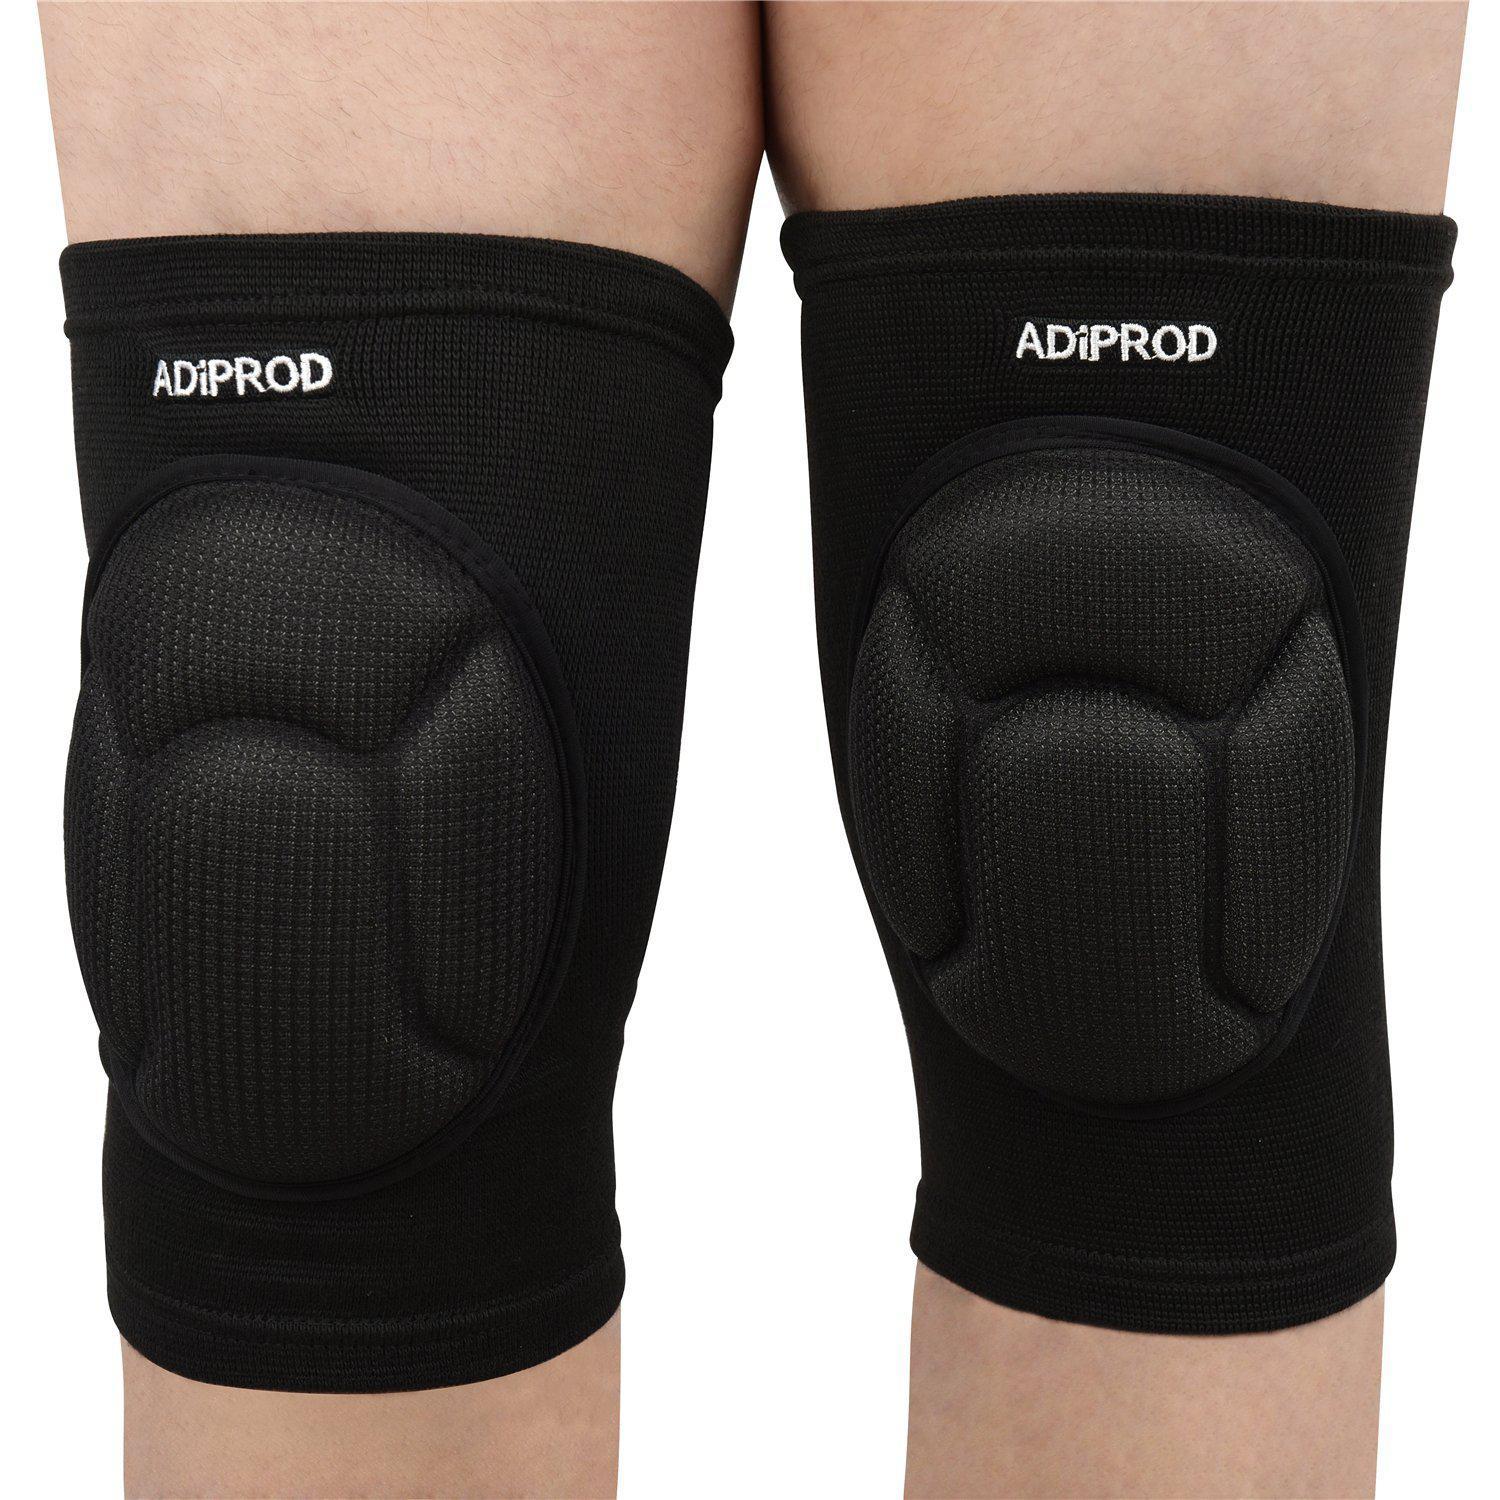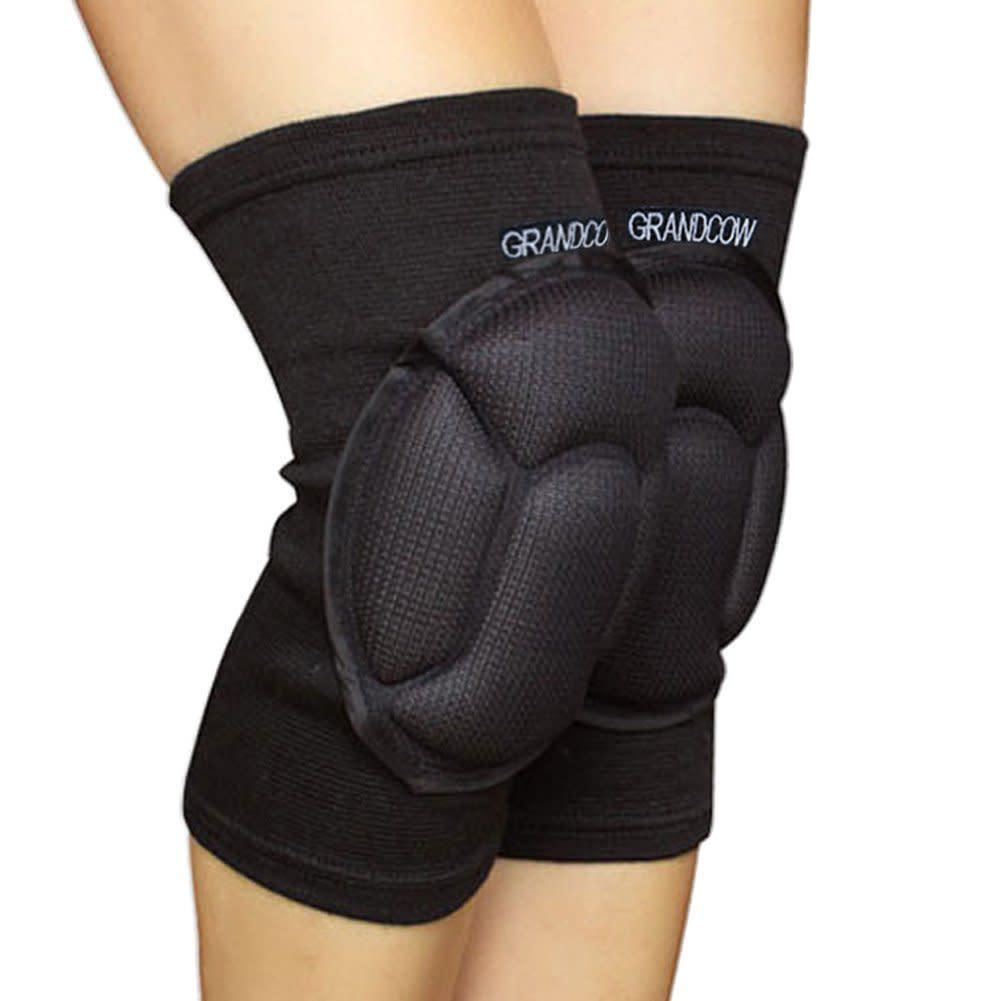The first image is the image on the left, the second image is the image on the right. Analyze the images presented: Is the assertion "Each image shows one pair of legs wearing a pair of knee pads." valid? Answer yes or no. Yes. The first image is the image on the left, the second image is the image on the right. Examine the images to the left and right. Is the description "There are four legs and four knee pads." accurate? Answer yes or no. Yes. 